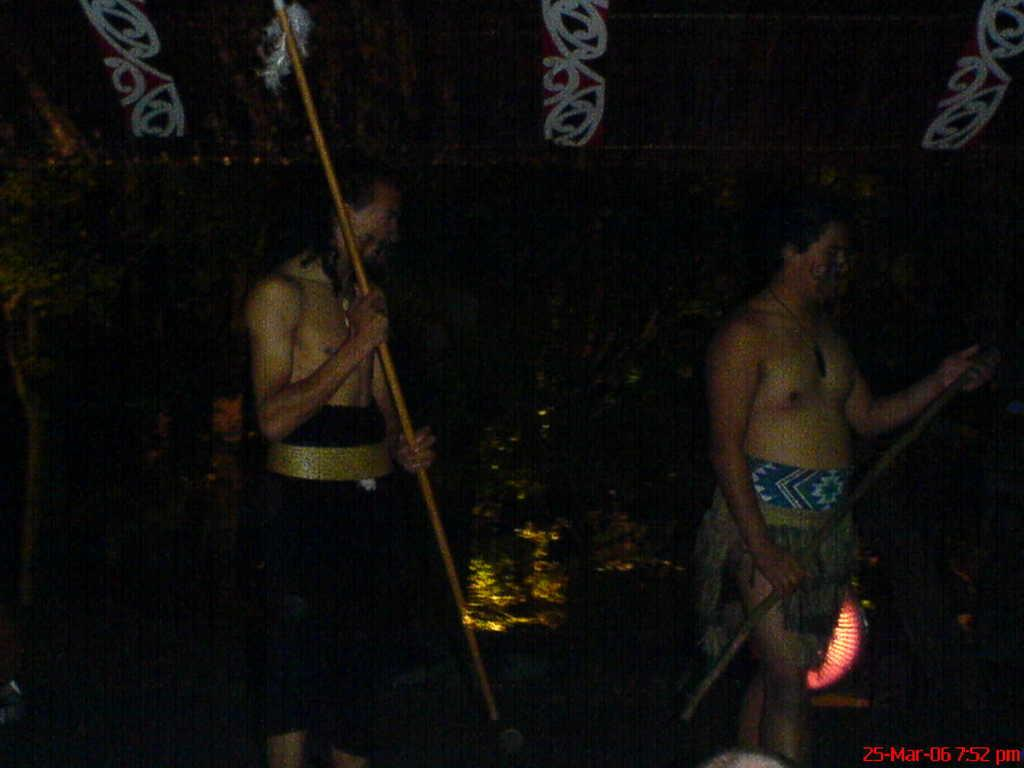How many people are in the image? There are two persons in the image. What are the persons doing in the image? The persons are standing and holding sticks. What can be seen in the background of the image? There are trees visible in the background of the image. What type of creature is standing next to the person holding the spoon in the image? There is no spoon present in the image, and no creature is visible. 